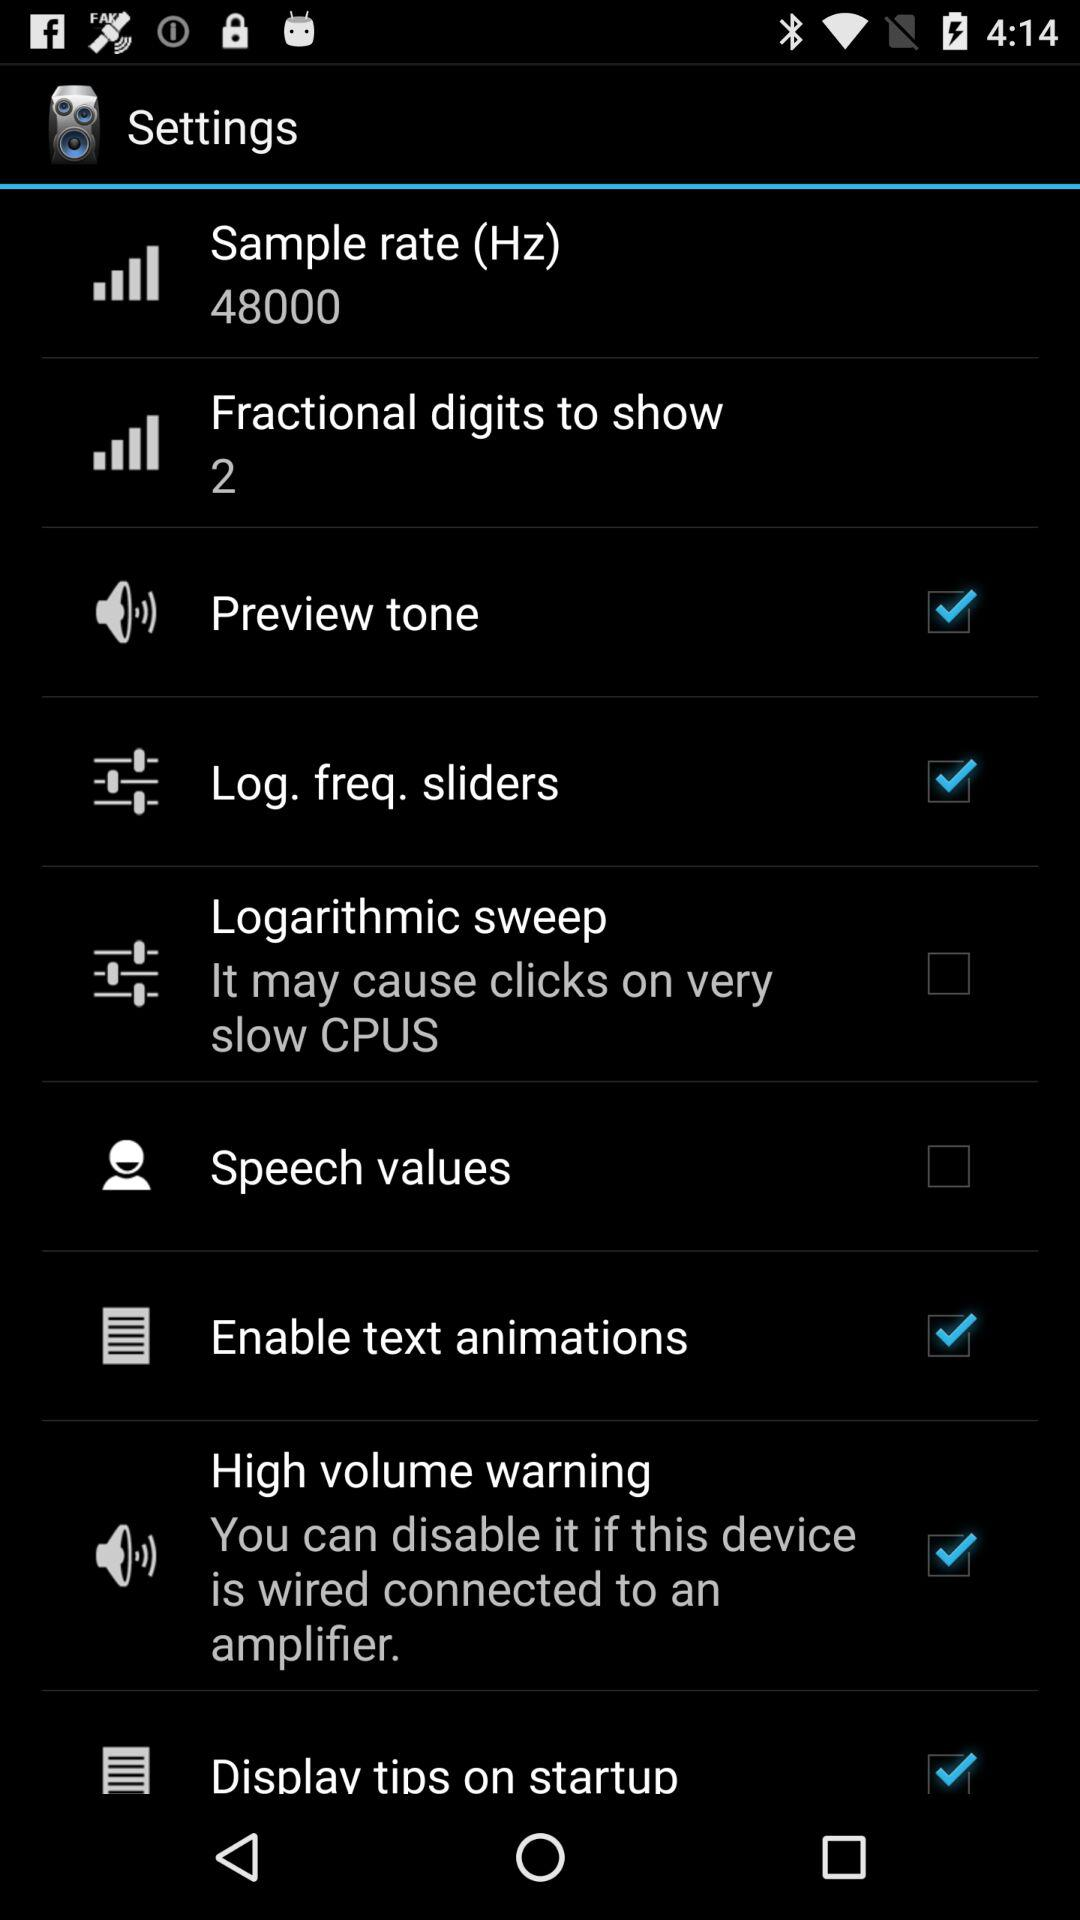What is the status of "Preview tone"? The status is "on". 